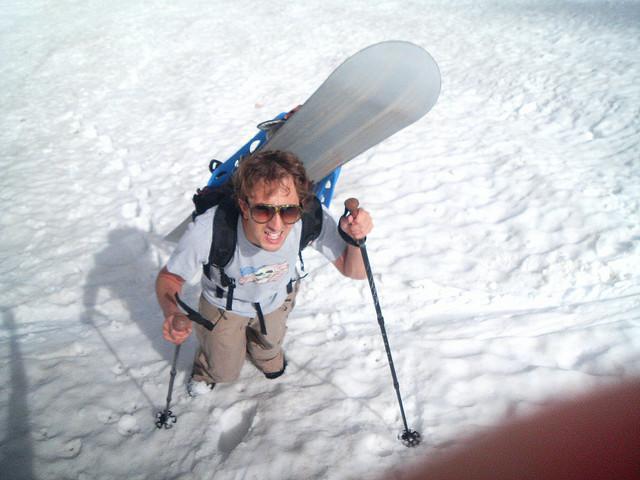What color is the bottom half of the snowboard which is carried up the hill by a man with ski poles?
Make your selection from the four choices given to correctly answer the question.
Options: Blue, white, red, purple. White. 